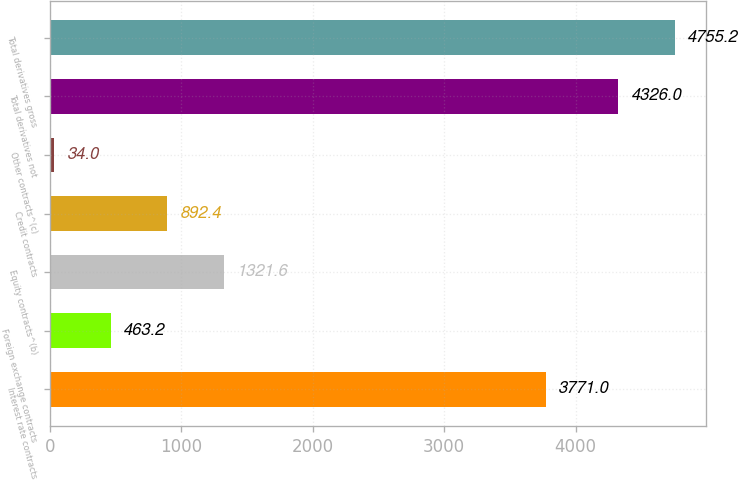<chart> <loc_0><loc_0><loc_500><loc_500><bar_chart><fcel>Interest rate contracts<fcel>Foreign exchange contracts<fcel>Equity contracts^(b)<fcel>Credit contracts<fcel>Other contracts^(c)<fcel>Total derivatives not<fcel>Total derivatives gross<nl><fcel>3771<fcel>463.2<fcel>1321.6<fcel>892.4<fcel>34<fcel>4326<fcel>4755.2<nl></chart> 